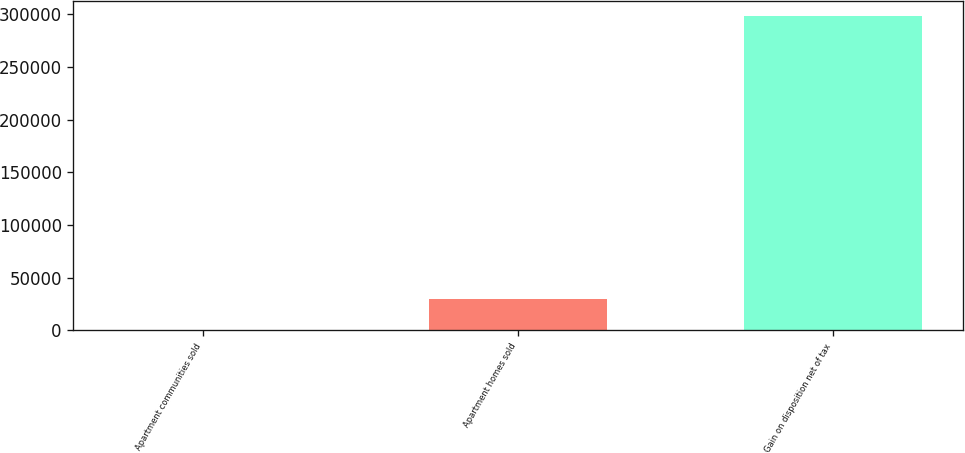Convert chart. <chart><loc_0><loc_0><loc_500><loc_500><bar_chart><fcel>Apartment communities sold<fcel>Apartment homes sold<fcel>Gain on disposition net of tax<nl><fcel>5<fcel>29798.9<fcel>297944<nl></chart> 